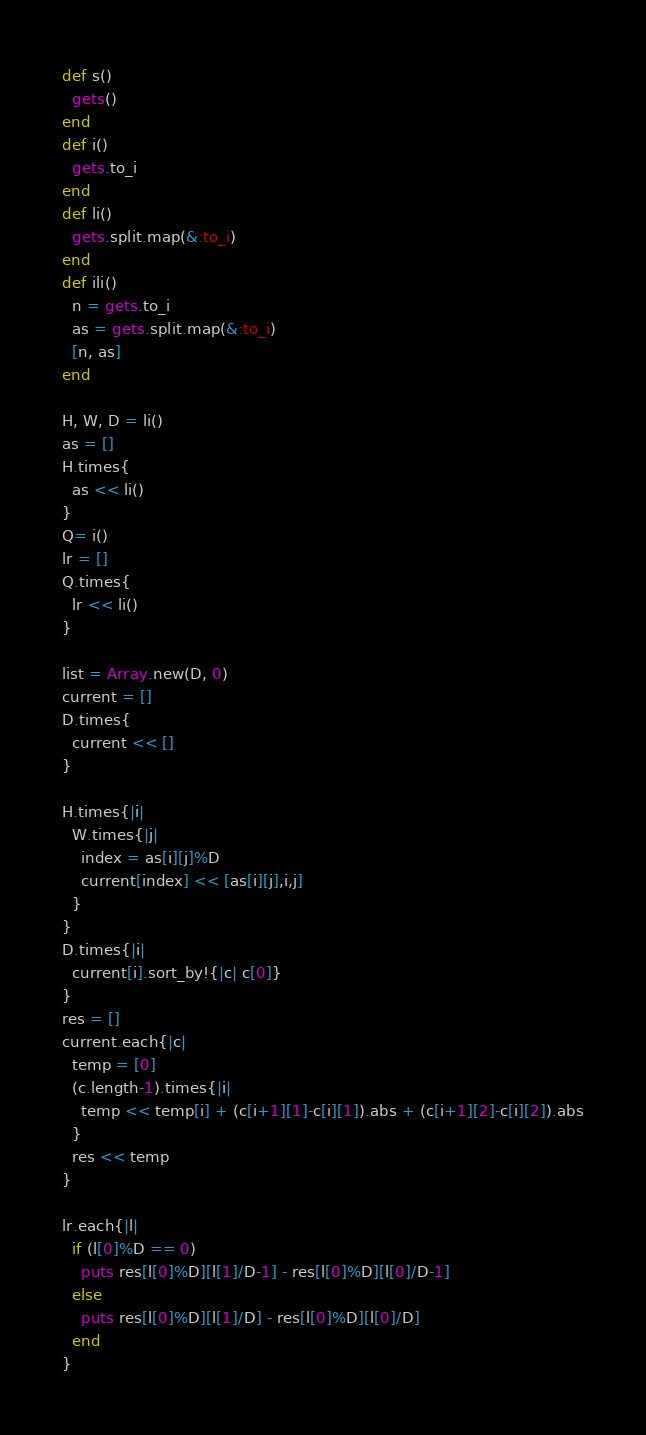Convert code to text. <code><loc_0><loc_0><loc_500><loc_500><_Ruby_>def s()
  gets()
end
def i()
  gets.to_i
end
def li()
  gets.split.map(&:to_i)
end
def ili()
  n = gets.to_i
  as = gets.split.map(&:to_i)
  [n, as]
end

H, W, D = li()
as = []
H.times{
  as << li()
}
Q= i()
lr = []
Q.times{
  lr << li()
}

list = Array.new(D, 0)
current = []
D.times{
  current << []
}

H.times{|i|
  W.times{|j|
    index = as[i][j]%D
    current[index] << [as[i][j],i,j]
  }
}
D.times{|i|
  current[i].sort_by!{|c| c[0]}
}
res = []
current.each{|c|
  temp = [0]
  (c.length-1).times{|i|
    temp << temp[i] + (c[i+1][1]-c[i][1]).abs + (c[i+1][2]-c[i][2]).abs
  }
  res << temp
}

lr.each{|l|
  if (l[0]%D == 0)
    puts res[l[0]%D][l[1]/D-1] - res[l[0]%D][l[0]/D-1]
  else
    puts res[l[0]%D][l[1]/D] - res[l[0]%D][l[0]/D]
  end
}</code> 